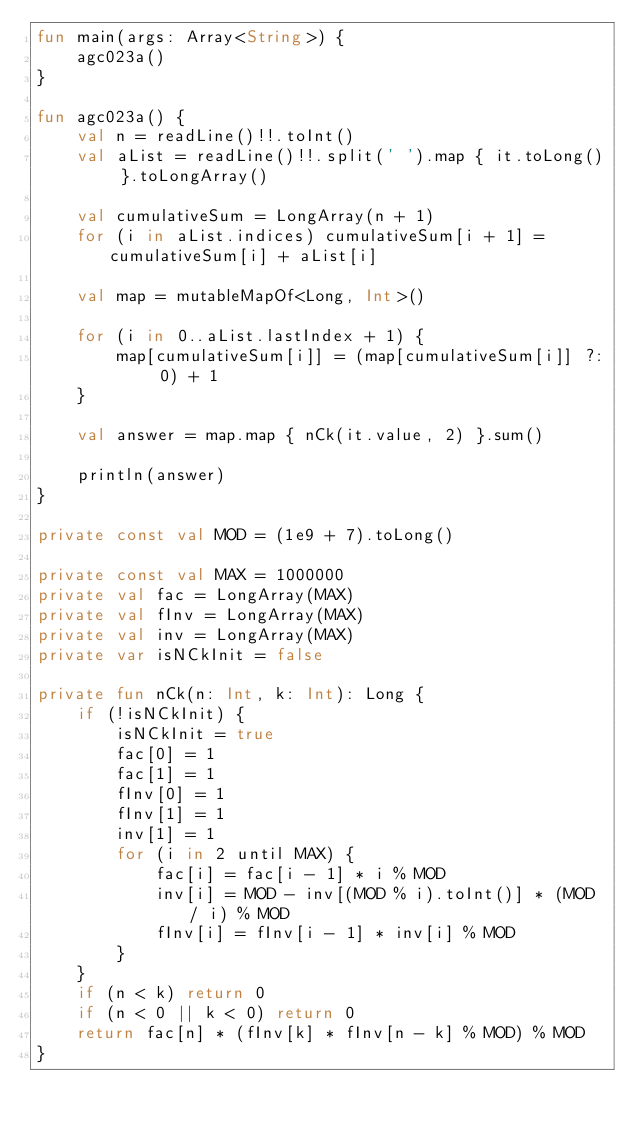<code> <loc_0><loc_0><loc_500><loc_500><_Kotlin_>fun main(args: Array<String>) {
    agc023a()
}

fun agc023a() {
    val n = readLine()!!.toInt()
    val aList = readLine()!!.split(' ').map { it.toLong() }.toLongArray()

    val cumulativeSum = LongArray(n + 1)
    for (i in aList.indices) cumulativeSum[i + 1] = cumulativeSum[i] + aList[i]

    val map = mutableMapOf<Long, Int>()

    for (i in 0..aList.lastIndex + 1) {
        map[cumulativeSum[i]] = (map[cumulativeSum[i]] ?: 0) + 1
    }

    val answer = map.map { nCk(it.value, 2) }.sum()

    println(answer)
}

private const val MOD = (1e9 + 7).toLong()

private const val MAX = 1000000
private val fac = LongArray(MAX)
private val fInv = LongArray(MAX)
private val inv = LongArray(MAX)
private var isNCkInit = false

private fun nCk(n: Int, k: Int): Long {
    if (!isNCkInit) {
        isNCkInit = true
        fac[0] = 1
        fac[1] = 1
        fInv[0] = 1
        fInv[1] = 1
        inv[1] = 1
        for (i in 2 until MAX) {
            fac[i] = fac[i - 1] * i % MOD
            inv[i] = MOD - inv[(MOD % i).toInt()] * (MOD / i) % MOD
            fInv[i] = fInv[i - 1] * inv[i] % MOD
        }
    }
    if (n < k) return 0
    if (n < 0 || k < 0) return 0
    return fac[n] * (fInv[k] * fInv[n - k] % MOD) % MOD
}
</code> 